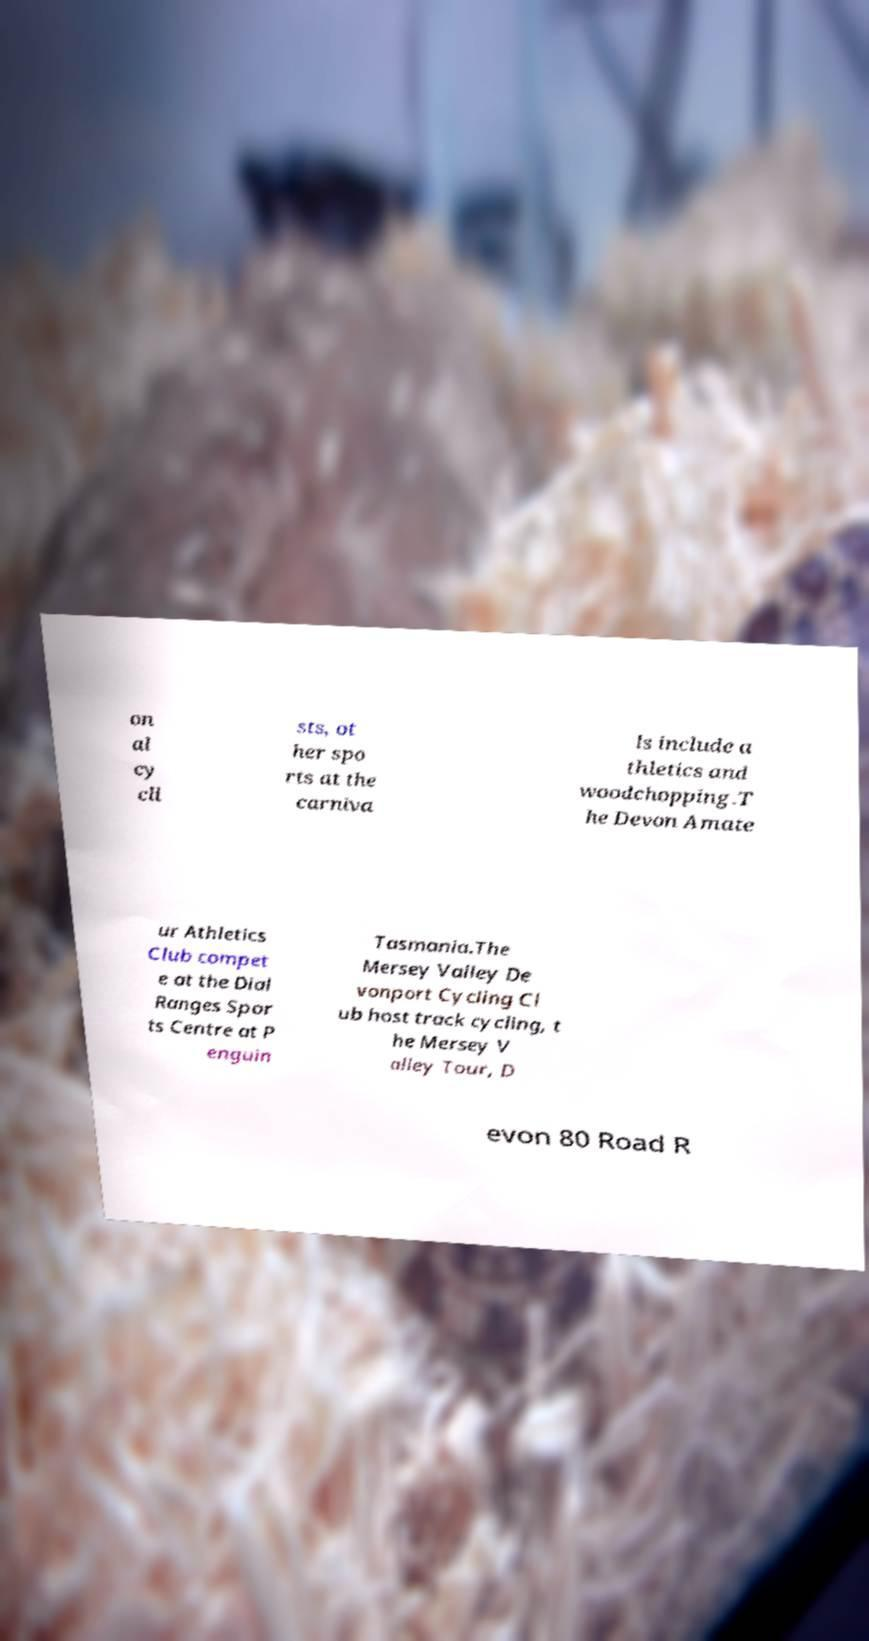Can you accurately transcribe the text from the provided image for me? on al cy cli sts, ot her spo rts at the carniva ls include a thletics and woodchopping.T he Devon Amate ur Athletics Club compet e at the Dial Ranges Spor ts Centre at P enguin Tasmania.The Mersey Valley De vonport Cycling Cl ub host track cycling, t he Mersey V alley Tour, D evon 80 Road R 